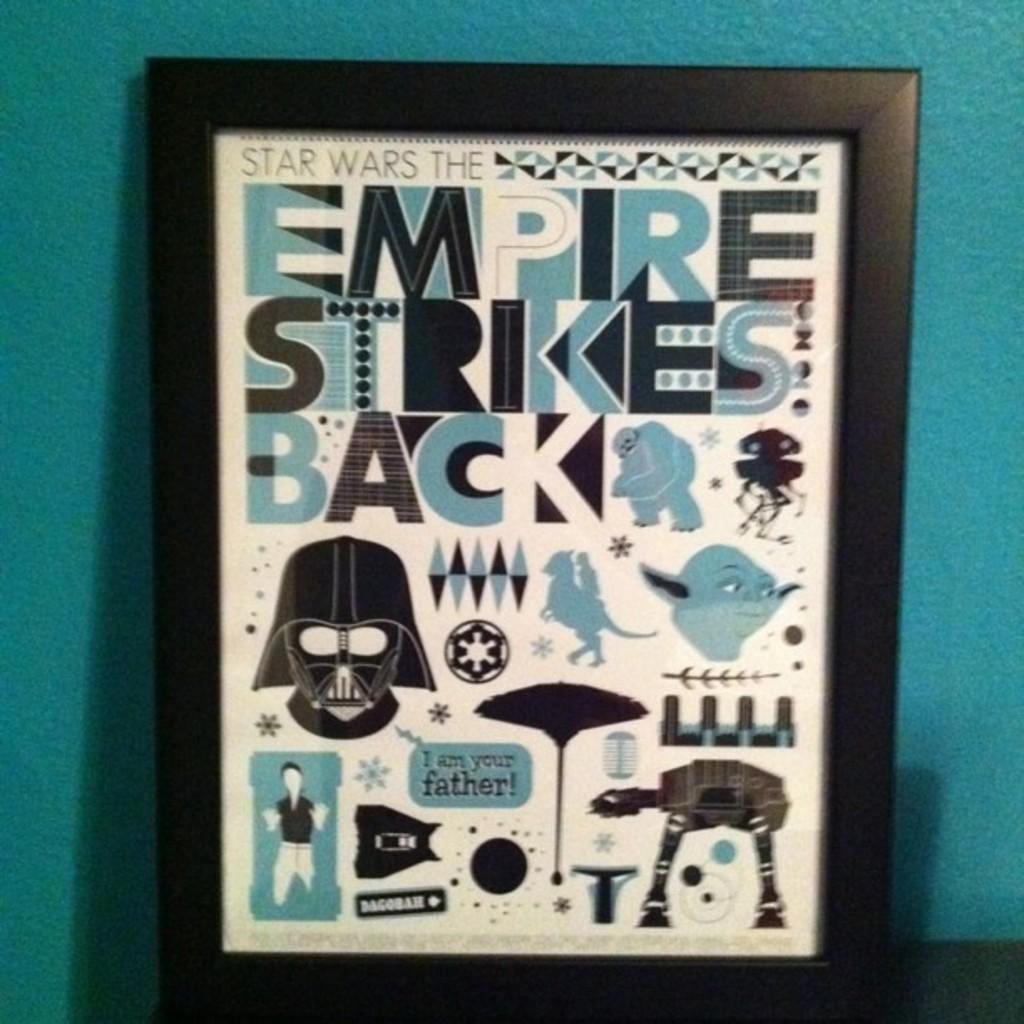Describe this image in one or two sentences. In this image we can see a photo frame which consists of some text, logos and pictures and behind it there is a wall which is in blue color. 